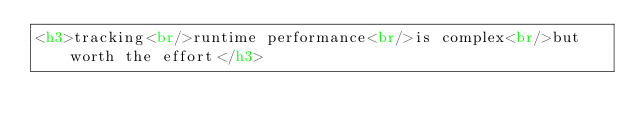Convert code to text. <code><loc_0><loc_0><loc_500><loc_500><_HTML_><h3>tracking<br/>runtime performance<br/>is complex<br/>but worth the effort</h3>
</code> 